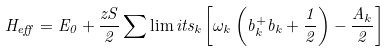Convert formula to latex. <formula><loc_0><loc_0><loc_500><loc_500>H _ { e f f } = E _ { 0 } + \frac { z S } { 2 } \sum \lim i t s _ { k } \left [ \omega _ { k } \left ( b _ { k } ^ { + } b _ { k } + \frac { 1 } { 2 } \right ) - \frac { A _ { k } } { 2 } \right ]</formula> 